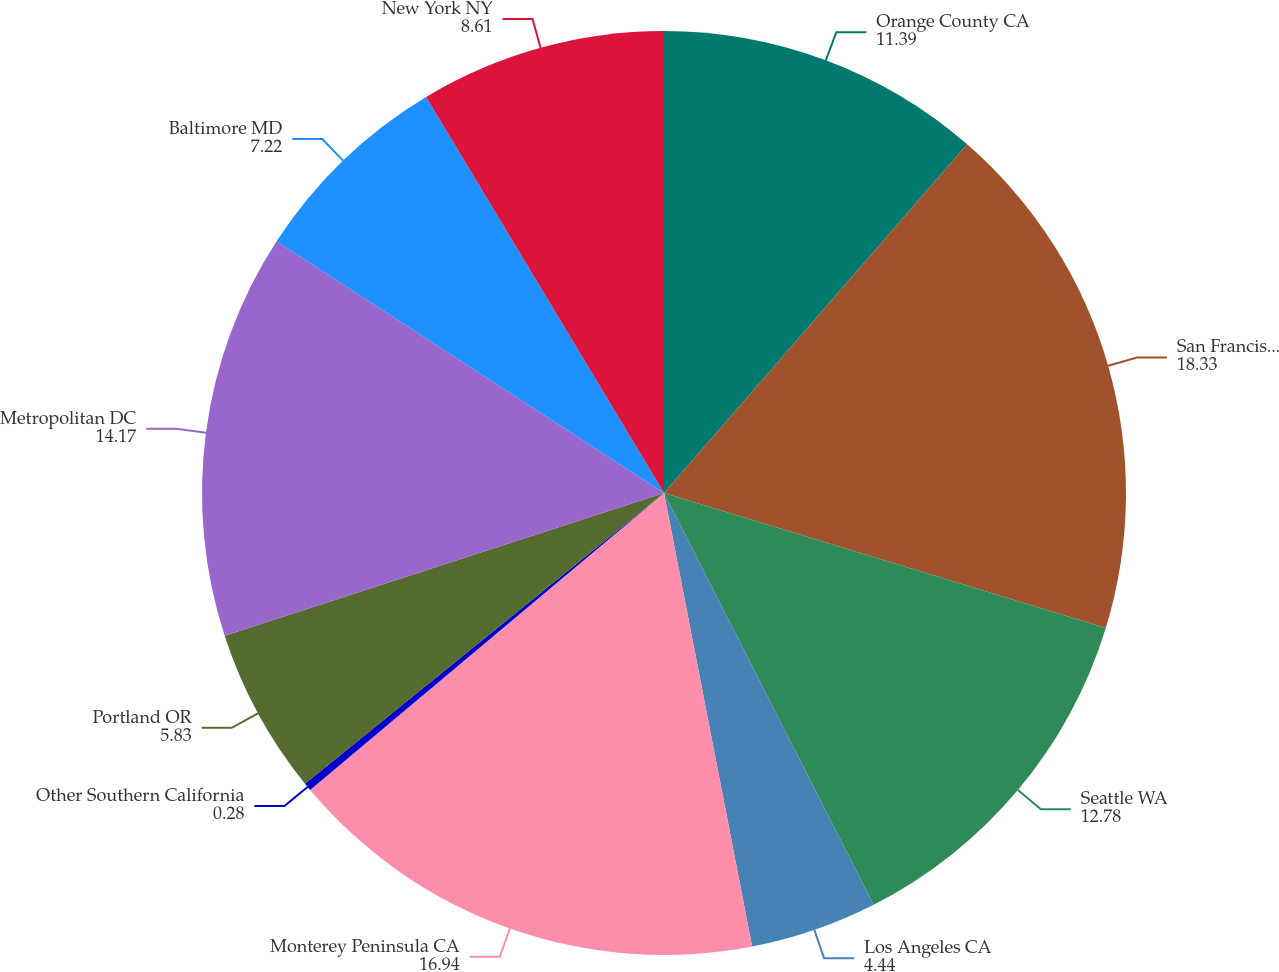Convert chart. <chart><loc_0><loc_0><loc_500><loc_500><pie_chart><fcel>Orange County CA<fcel>San Francisco CA<fcel>Seattle WA<fcel>Los Angeles CA<fcel>Monterey Peninsula CA<fcel>Other Southern California<fcel>Portland OR<fcel>Metropolitan DC<fcel>Baltimore MD<fcel>New York NY<nl><fcel>11.39%<fcel>18.33%<fcel>12.78%<fcel>4.44%<fcel>16.94%<fcel>0.28%<fcel>5.83%<fcel>14.17%<fcel>7.22%<fcel>8.61%<nl></chart> 